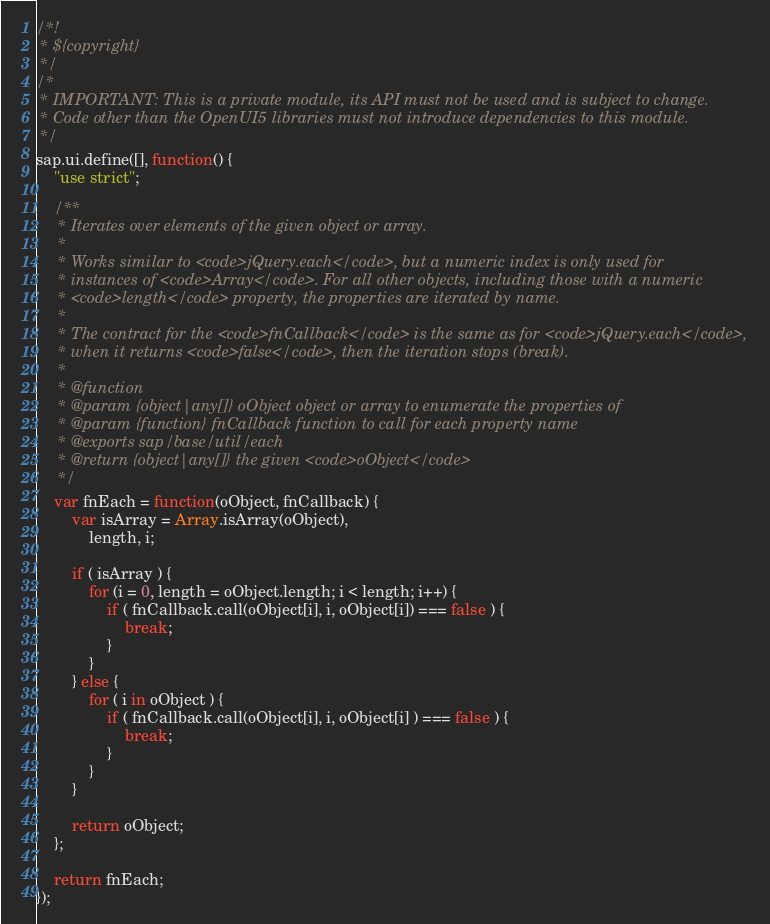<code> <loc_0><loc_0><loc_500><loc_500><_JavaScript_>/*!
 * ${copyright}
 */
/*
 * IMPORTANT: This is a private module, its API must not be used and is subject to change.
 * Code other than the OpenUI5 libraries must not introduce dependencies to this module.
 */
sap.ui.define([], function() {
	"use strict";

	/**
	 * Iterates over elements of the given object or array.
	 *
	 * Works similar to <code>jQuery.each</code>, but a numeric index is only used for
	 * instances of <code>Array</code>. For all other objects, including those with a numeric
	 * <code>length</code> property, the properties are iterated by name.
	 *
	 * The contract for the <code>fnCallback</code> is the same as for <code>jQuery.each</code>,
	 * when it returns <code>false</code>, then the iteration stops (break).
	 *
	 * @function
	 * @param {object|any[]} oObject object or array to enumerate the properties of
	 * @param {function} fnCallback function to call for each property name
	 * @exports sap/base/util/each
	 * @return {object|any[]} the given <code>oObject</code>
	 */
	var fnEach = function(oObject, fnCallback) {
		var isArray = Array.isArray(oObject),
			length, i;

		if ( isArray ) {
			for (i = 0, length = oObject.length; i < length; i++) {
				if ( fnCallback.call(oObject[i], i, oObject[i]) === false ) {
					break;
				}
			}
		} else {
			for ( i in oObject ) {
				if ( fnCallback.call(oObject[i], i, oObject[i] ) === false ) {
					break;
				}
			}
		}

		return oObject;
	};

	return fnEach;
});
</code> 